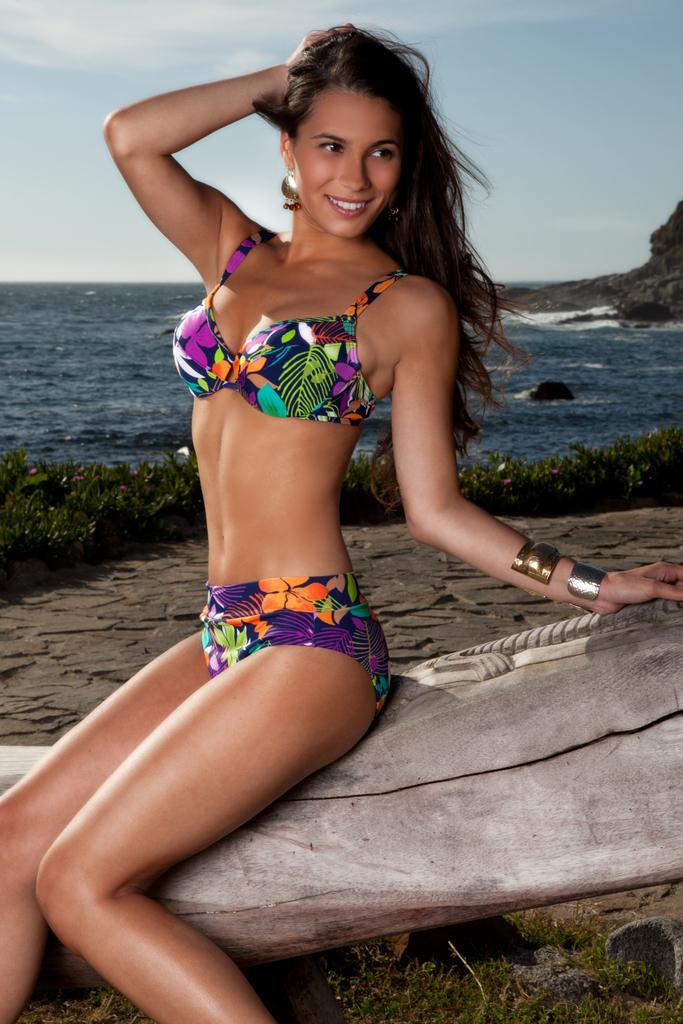Please provide a concise description of this image. This woman is sitting on a branch and smiling. Background we can see the sky, grass and water.  